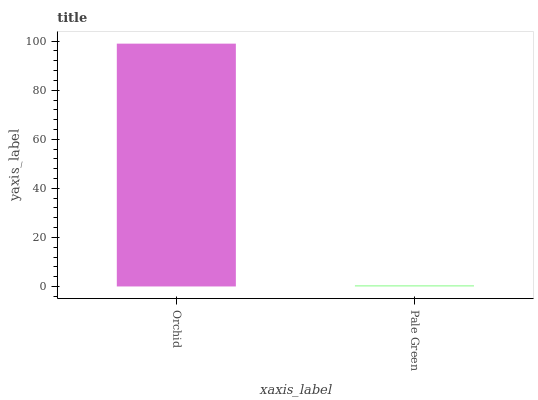Is Pale Green the minimum?
Answer yes or no. Yes. Is Orchid the maximum?
Answer yes or no. Yes. Is Pale Green the maximum?
Answer yes or no. No. Is Orchid greater than Pale Green?
Answer yes or no. Yes. Is Pale Green less than Orchid?
Answer yes or no. Yes. Is Pale Green greater than Orchid?
Answer yes or no. No. Is Orchid less than Pale Green?
Answer yes or no. No. Is Orchid the high median?
Answer yes or no. Yes. Is Pale Green the low median?
Answer yes or no. Yes. Is Pale Green the high median?
Answer yes or no. No. Is Orchid the low median?
Answer yes or no. No. 